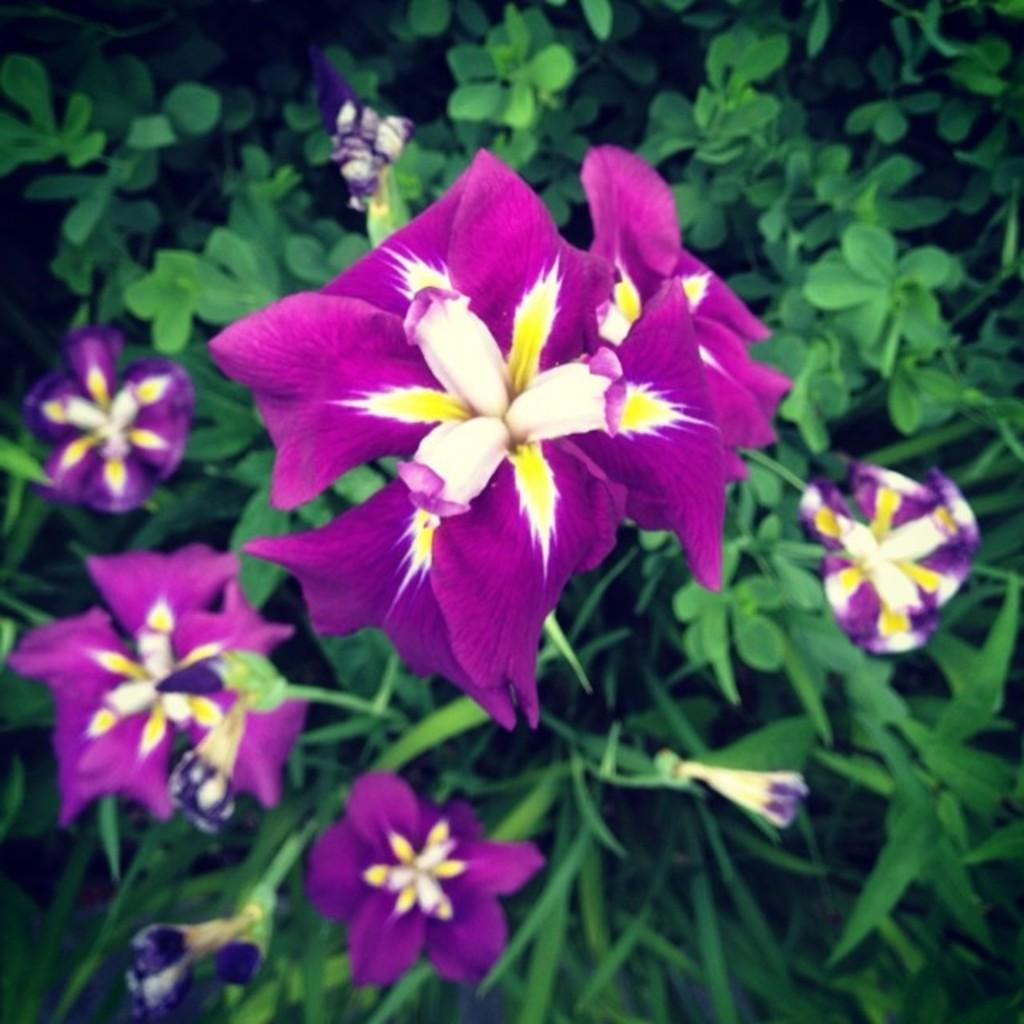What type of plant life can be seen in the image? There are flowers and leaves in the image in the image. Can you describe the flowers in the image? Unfortunately, the facts provided do not give specific details about the flowers. What is the relationship between the flowers and leaves in the image? The flowers and leaves are likely part of the same plant or plants, but the facts do not specify their exact relationship. What type of bell can be seen hanging from the leaves in the image? There is no bell present in the image; it only features flowers and leaves. Can you describe the zebra grazing among the flowers in the image? There is no zebra present in the image; it only features flowers and leaves. 